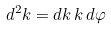<formula> <loc_0><loc_0><loc_500><loc_500>d ^ { 2 } k = d k \, k \, d \varphi</formula> 